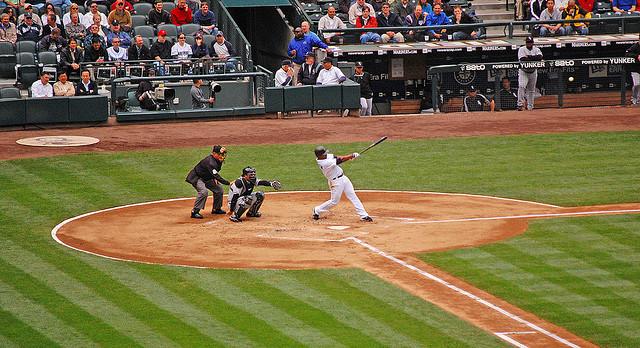Is there a crowd watching this game?
Keep it brief. Yes. What is the technical name of the person crouched down on the field?
Answer briefly. Catcher. Has he swung the bat?
Quick response, please. Yes. Is it raining?
Concise answer only. No. 